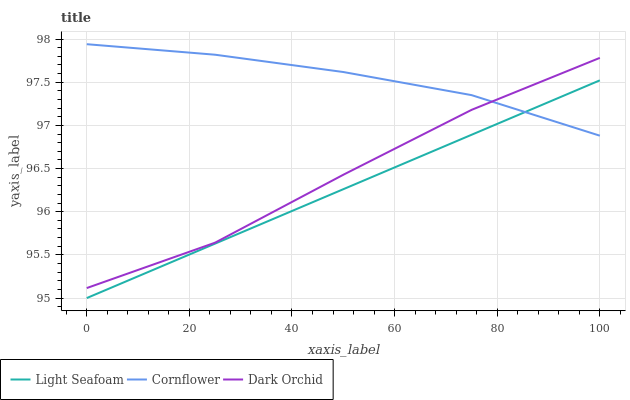Does Light Seafoam have the minimum area under the curve?
Answer yes or no. Yes. Does Cornflower have the maximum area under the curve?
Answer yes or no. Yes. Does Dark Orchid have the minimum area under the curve?
Answer yes or no. No. Does Dark Orchid have the maximum area under the curve?
Answer yes or no. No. Is Light Seafoam the smoothest?
Answer yes or no. Yes. Is Dark Orchid the roughest?
Answer yes or no. Yes. Is Dark Orchid the smoothest?
Answer yes or no. No. Is Light Seafoam the roughest?
Answer yes or no. No. Does Light Seafoam have the lowest value?
Answer yes or no. Yes. Does Dark Orchid have the lowest value?
Answer yes or no. No. Does Cornflower have the highest value?
Answer yes or no. Yes. Does Dark Orchid have the highest value?
Answer yes or no. No. Is Light Seafoam less than Dark Orchid?
Answer yes or no. Yes. Is Dark Orchid greater than Light Seafoam?
Answer yes or no. Yes. Does Light Seafoam intersect Cornflower?
Answer yes or no. Yes. Is Light Seafoam less than Cornflower?
Answer yes or no. No. Is Light Seafoam greater than Cornflower?
Answer yes or no. No. Does Light Seafoam intersect Dark Orchid?
Answer yes or no. No. 